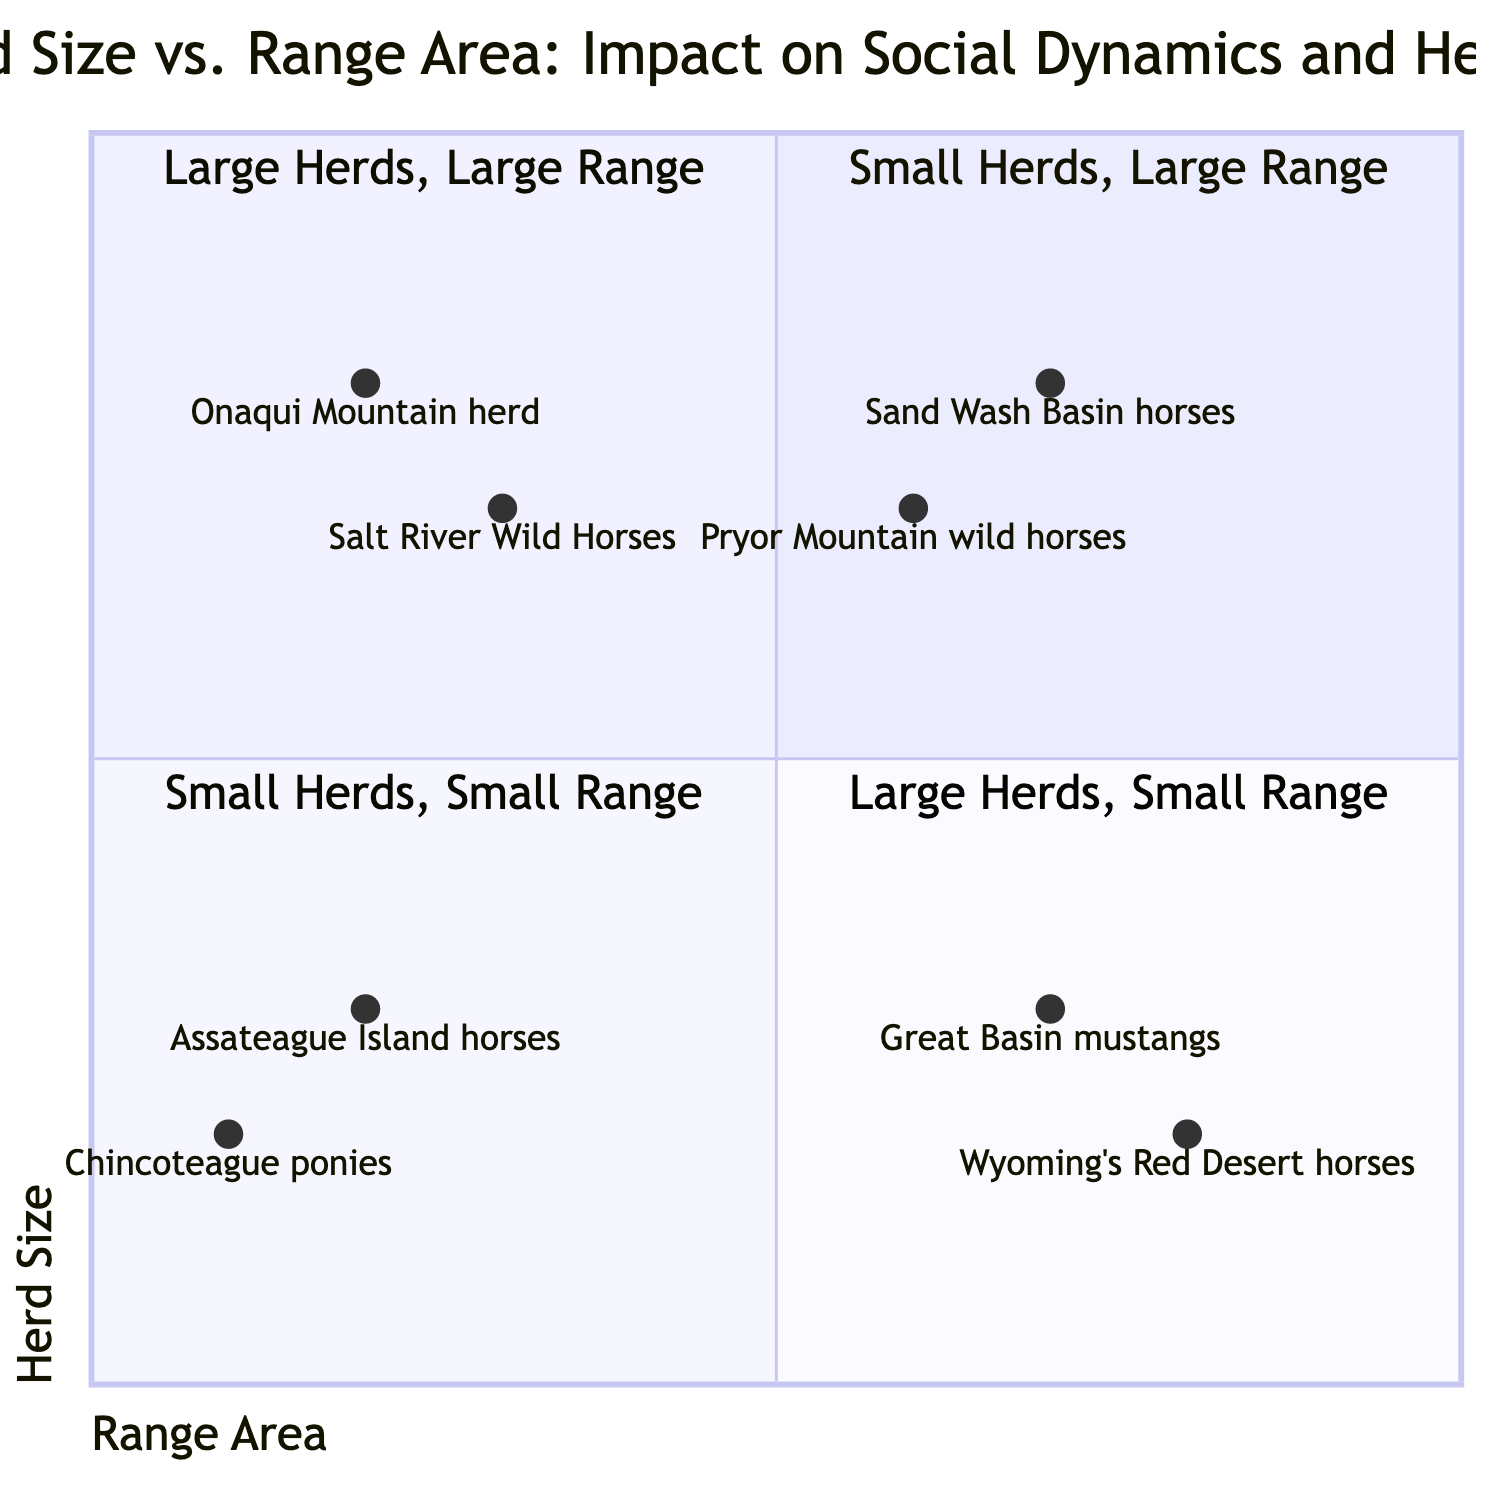What is the name of the quadrant where large herds with small range are located? The quadrant that describes large herds with a small range is called "Large Herds, Small Range." This can be directly identified on the quadrant chart.
Answer: Large Herds, Small Range How many examples are listed for the "Small Herds, Large Range" quadrant? The "Small Herds, Large Range" quadrant has two examples listed: "Great Basin mustangs" and "Wyoming’s Red Desert horses." By counting the entries, we find two.
Answer: 2 Which herd is located in the "Small Herds, Small Range" quadrant? The herd located in the "Small Herds, Small Range" quadrant is "Assateague Island horses," as shown in the examples of that section.
Answer: Assateague Island horses What are the characteristics of the "Large Herds, Large Range" quadrant? The characteristics of the "Large Herds, Large Range" quadrant include "Complex social networks," "Better resource distribution," and "Challenges in monitoring health." This can be derived from the quadrant's description.
Answer: Complex social networks, Better resource distribution, Challenges in monitoring health What is the relationship between herd size and resource competition in the "Small Herds, Small Range" quadrant? In the "Small Herds, Small Range" quadrant, there is increased resource competition due to the smaller range size against a limited number of resources, which often leads to overgrazing. This relationship is described in the quadrant's characteristics.
Answer: Increased resource competition In which quadrant would you classify Pryor Mountain wild horses? The Pryor Mountain wild horses are classified in the "Large Herds, Large Range" quadrant, as indicated by their examples corresponding to that area of the chart.
Answer: Large Herds, Large Range What is the expected risk of disease transmission for herds in the "Small Herds, Large Range" quadrant? The expected risk of disease transmission in the "Small Herds, Large Range" quadrant is lower, as characterized by the resources being adequate per individual and more space to maintain distance among horses.
Answer: Lower disease transmission risk Which two herds are found in the "Large Herds, Small Range" quadrant? The two herds found in the "Large Herds, Small Range" quadrant are "Salt River Wild Horses" and "Onaqui Mountain herd." This can be confirmed by reviewing the examples listed in that section.
Answer: Salt River Wild Horses, Onaqui Mountain herd What are some of the social dynamics indicated for large herds occupying small ranges? The social dynamics indicated for large herds occupying small ranges include "Frequent social hierarchies," "High competition for food and water," and "Potential for increased stress and aggression," as reflected in their quadrant characteristics.
Answer: Frequent social hierarchies, High competition for food and water, Potential for increased stress and aggression 